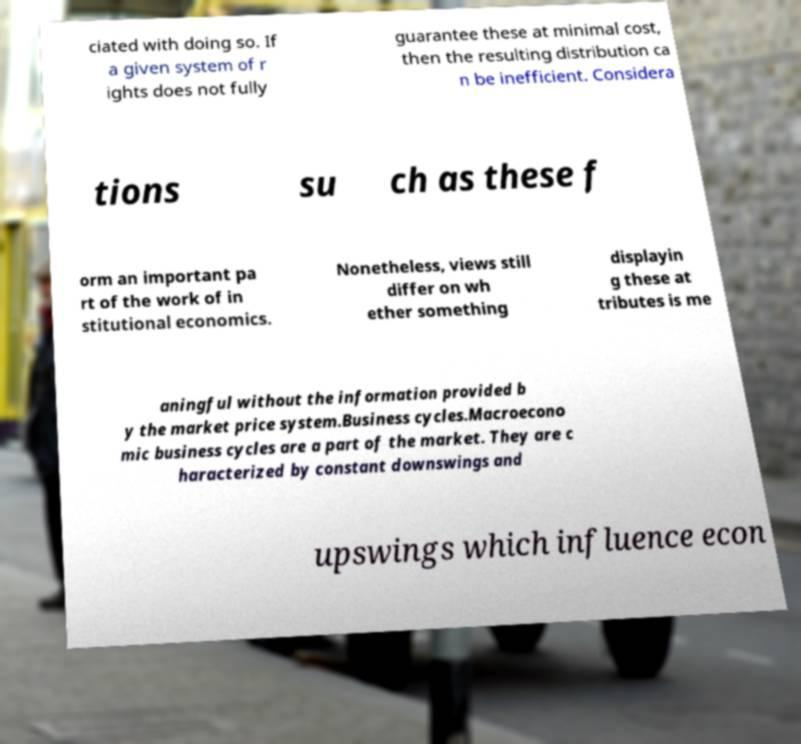Please read and relay the text visible in this image. What does it say? ciated with doing so. If a given system of r ights does not fully guarantee these at minimal cost, then the resulting distribution ca n be inefficient. Considera tions su ch as these f orm an important pa rt of the work of in stitutional economics. Nonetheless, views still differ on wh ether something displayin g these at tributes is me aningful without the information provided b y the market price system.Business cycles.Macroecono mic business cycles are a part of the market. They are c haracterized by constant downswings and upswings which influence econ 